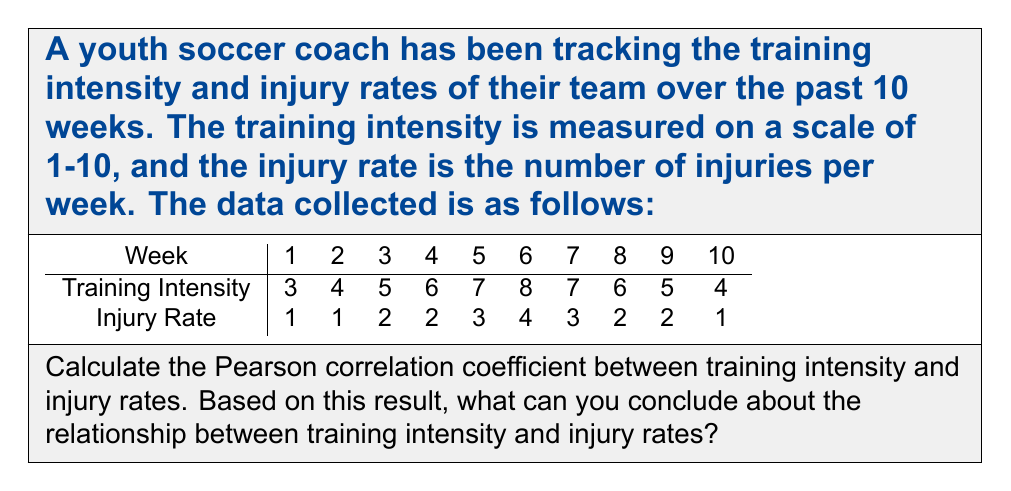Solve this math problem. To calculate the Pearson correlation coefficient, we'll use the formula:

$$ r = \frac{\sum_{i=1}^{n} (x_i - \bar{x})(y_i - \bar{y})}{\sqrt{\sum_{i=1}^{n} (x_i - \bar{x})^2} \sqrt{\sum_{i=1}^{n} (y_i - \bar{y})^2}} $$

Where:
$x_i$ = training intensity values
$y_i$ = injury rate values
$\bar{x}$ = mean of training intensity
$\bar{y}$ = mean of injury rate
$n$ = number of data points (10 in this case)

Step 1: Calculate means
$\bar{x} = \frac{3 + 4 + 5 + 6 + 7 + 8 + 7 + 6 + 5 + 4}{10} = 5.5$
$\bar{y} = \frac{1 + 1 + 2 + 2 + 3 + 4 + 3 + 2 + 2 + 1}{10} = 2.1$

Step 2: Calculate $(x_i - \bar{x})$, $(y_i - \bar{y})$, $(x_i - \bar{x})^2$, $(y_i - \bar{y})^2$, and $(x_i - \bar{x})(y_i - \bar{y})$ for each data point.

Step 3: Sum up the calculated values:
$\sum (x_i - \bar{x})(y_i - \bar{y}) = 11.5$
$\sum (x_i - \bar{x})^2 = 27.5$
$\sum (y_i - \bar{y})^2 = 8.9$

Step 4: Apply the formula:

$$ r = \frac{11.5}{\sqrt{27.5} \sqrt{8.9}} \approx 0.8276 $$

The Pearson correlation coefficient is approximately 0.8276.

Interpretation:
- The correlation coefficient ranges from -1 to 1.
- A value of 0.8276 indicates a strong positive correlation between training intensity and injury rates.
- This suggests that as training intensity increases, injury rates tend to increase as well.

However, it's important to note that correlation does not imply causation. Other factors may be influencing this relationship, and further investigation would be needed to determine if training intensity directly causes increased injuries.
Answer: The Pearson correlation coefficient between training intensity and injury rates is approximately 0.8276, indicating a strong positive correlation between the two variables. 